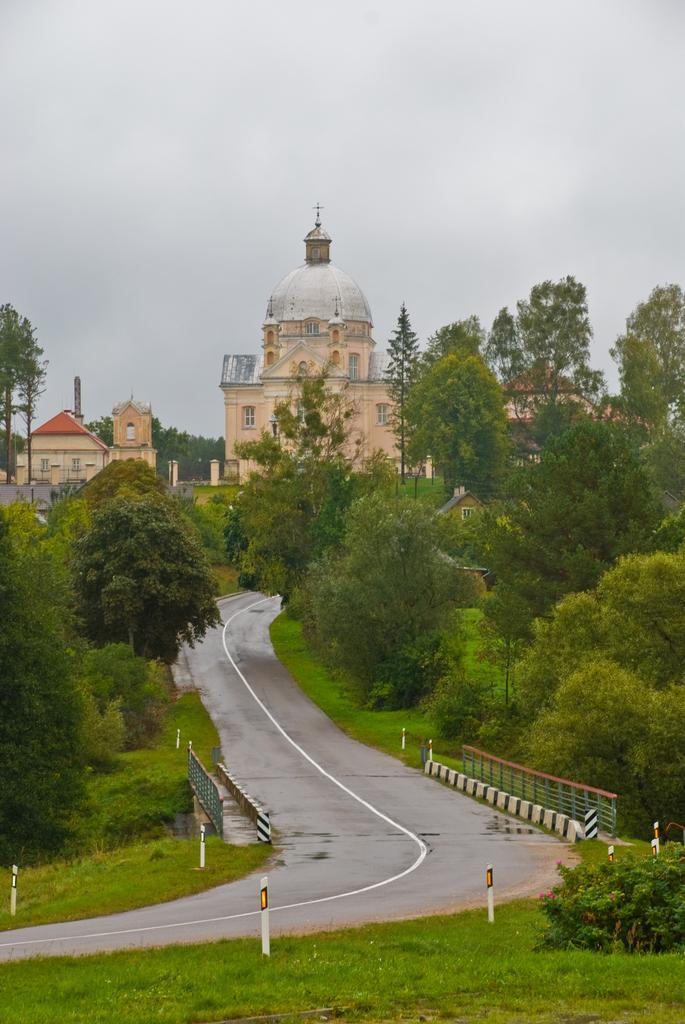Could you give a brief overview of what you see in this image? In this picture we can see the road, poles, grass, trees, buildings with windows and in the background we can see the sky with clouds. 